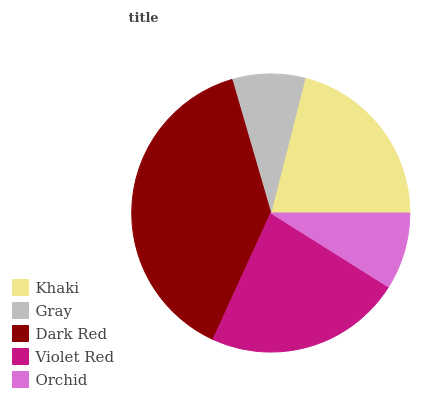Is Gray the minimum?
Answer yes or no. Yes. Is Dark Red the maximum?
Answer yes or no. Yes. Is Dark Red the minimum?
Answer yes or no. No. Is Gray the maximum?
Answer yes or no. No. Is Dark Red greater than Gray?
Answer yes or no. Yes. Is Gray less than Dark Red?
Answer yes or no. Yes. Is Gray greater than Dark Red?
Answer yes or no. No. Is Dark Red less than Gray?
Answer yes or no. No. Is Khaki the high median?
Answer yes or no. Yes. Is Khaki the low median?
Answer yes or no. Yes. Is Orchid the high median?
Answer yes or no. No. Is Gray the low median?
Answer yes or no. No. 